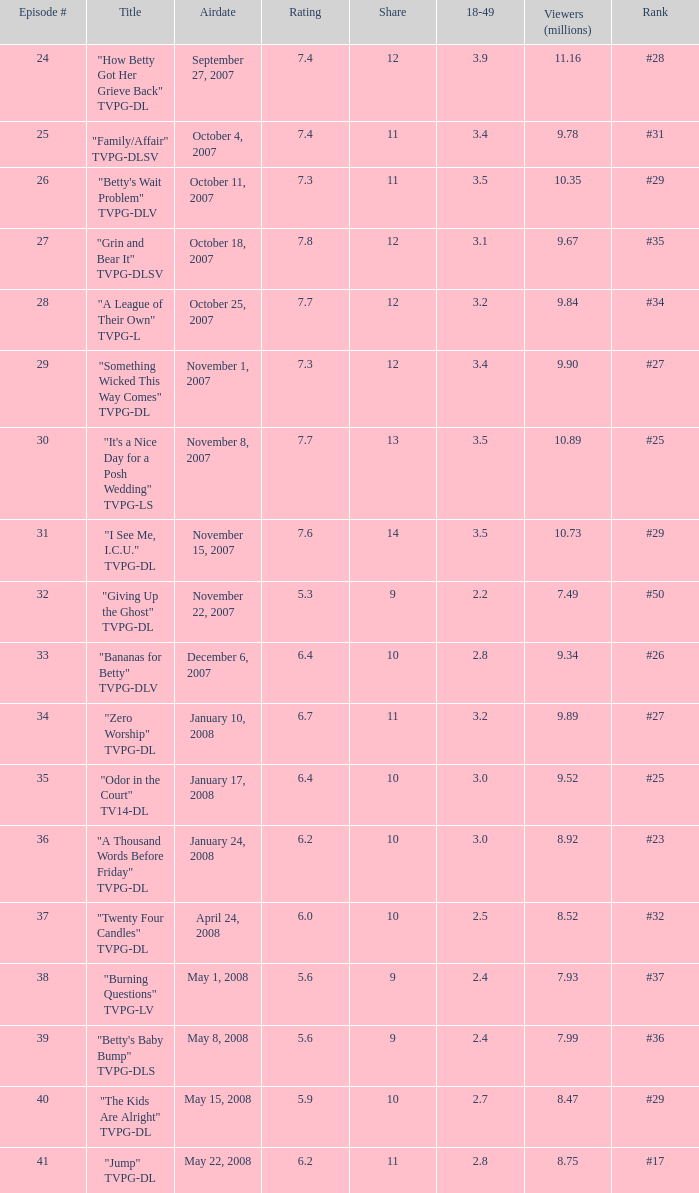Would you mind parsing the complete table? {'header': ['Episode #', 'Title', 'Airdate', 'Rating', 'Share', '18-49', 'Viewers (millions)', 'Rank'], 'rows': [['24', '"How Betty Got Her Grieve Back" TVPG-DL', 'September 27, 2007', '7.4', '12', '3.9', '11.16', '#28'], ['25', '"Family/Affair" TVPG-DLSV', 'October 4, 2007', '7.4', '11', '3.4', '9.78', '#31'], ['26', '"Betty\'s Wait Problem" TVPG-DLV', 'October 11, 2007', '7.3', '11', '3.5', '10.35', '#29'], ['27', '"Grin and Bear It" TVPG-DLSV', 'October 18, 2007', '7.8', '12', '3.1', '9.67', '#35'], ['28', '"A League of Their Own" TVPG-L', 'October 25, 2007', '7.7', '12', '3.2', '9.84', '#34'], ['29', '"Something Wicked This Way Comes" TVPG-DL', 'November 1, 2007', '7.3', '12', '3.4', '9.90', '#27'], ['30', '"It\'s a Nice Day for a Posh Wedding" TVPG-LS', 'November 8, 2007', '7.7', '13', '3.5', '10.89', '#25'], ['31', '"I See Me, I.C.U." TVPG-DL', 'November 15, 2007', '7.6', '14', '3.5', '10.73', '#29'], ['32', '"Giving Up the Ghost" TVPG-DL', 'November 22, 2007', '5.3', '9', '2.2', '7.49', '#50'], ['33', '"Bananas for Betty" TVPG-DLV', 'December 6, 2007', '6.4', '10', '2.8', '9.34', '#26'], ['34', '"Zero Worship" TVPG-DL', 'January 10, 2008', '6.7', '11', '3.2', '9.89', '#27'], ['35', '"Odor in the Court" TV14-DL', 'January 17, 2008', '6.4', '10', '3.0', '9.52', '#25'], ['36', '"A Thousand Words Before Friday" TVPG-DL', 'January 24, 2008', '6.2', '10', '3.0', '8.92', '#23'], ['37', '"Twenty Four Candles" TVPG-DL', 'April 24, 2008', '6.0', '10', '2.5', '8.52', '#32'], ['38', '"Burning Questions" TVPG-LV', 'May 1, 2008', '5.6', '9', '2.4', '7.93', '#37'], ['39', '"Betty\'s Baby Bump" TVPG-DLS', 'May 8, 2008', '5.6', '9', '2.4', '7.99', '#36'], ['40', '"The Kids Are Alright" TVPG-DL', 'May 15, 2008', '5.9', '10', '2.7', '8.47', '#29'], ['41', '"Jump" TVPG-DL', 'May 22, 2008', '6.2', '11', '2.8', '8.75', '#17']]} What is the release date of the episode that ranked #29 and had a share greater than 10? May 15, 2008. 